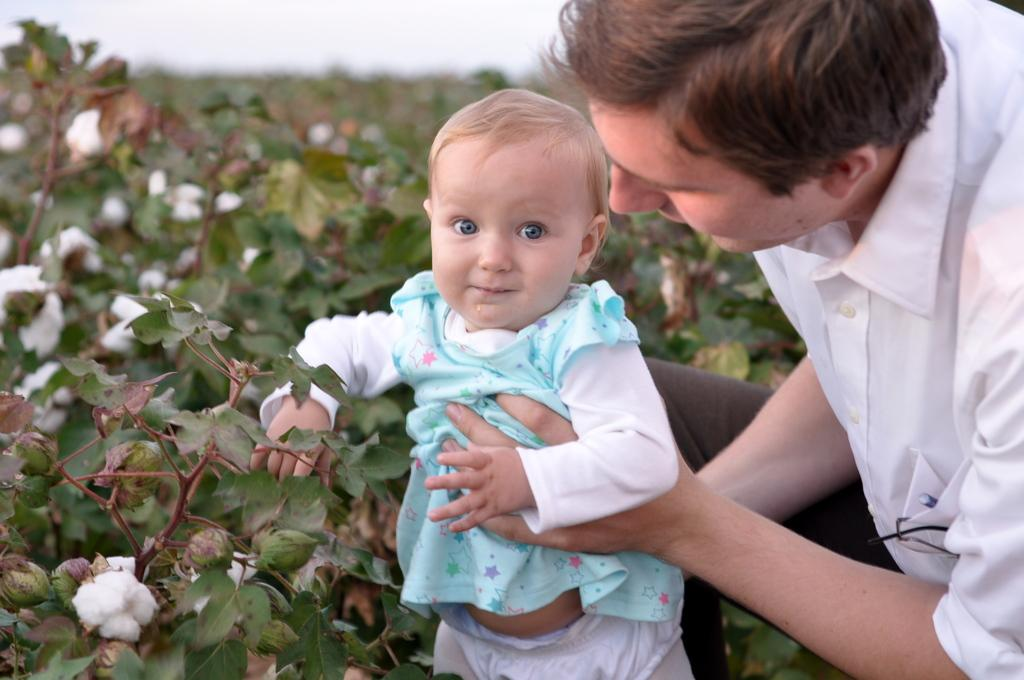What is the man doing in the image? The man is holding a baby in the image. What type of plants can be seen in the image? There are cotton plants in the image. Can you describe the background of the image? The background of the image is blurry. What part of the baby's body is covered in a cobweb in the image? There is no cobweb present in the image, and therefore no part of the baby's body is covered by one. 